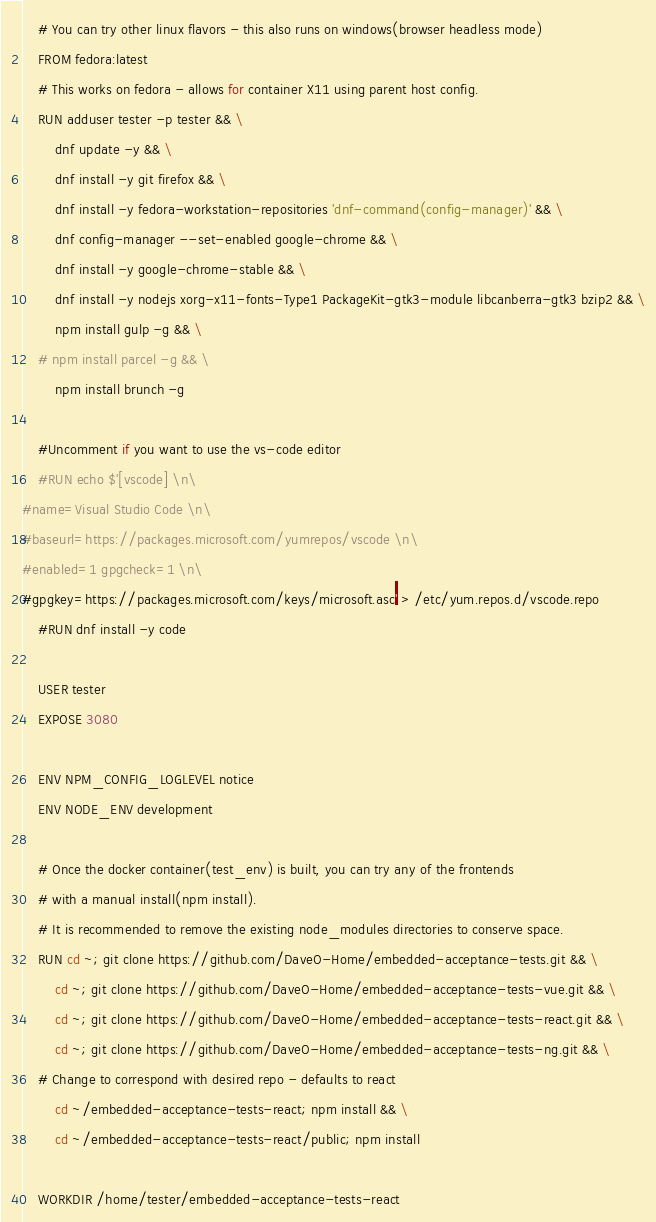<code> <loc_0><loc_0><loc_500><loc_500><_Dockerfile_>    # You can try other linux flavors - this also runs on windows(browser headless mode)
    FROM fedora:latest
    # This works on fedora - allows for container X11 using parent host config.
    RUN adduser tester -p tester && \
        dnf update -y && \
        dnf install -y git firefox && \
        dnf install -y fedora-workstation-repositories 'dnf-command(config-manager)' && \
        dnf config-manager --set-enabled google-chrome && \
        dnf install -y google-chrome-stable && \
        dnf install -y nodejs xorg-x11-fonts-Type1 PackageKit-gtk3-module libcanberra-gtk3 bzip2 && \
        npm install gulp -g && \
    # npm install parcel -g && \
        npm install brunch -g

    #Uncomment if you want to use the vs-code editor
    #RUN echo $'[vscode] \n\
#name=Visual Studio Code \n\
#baseurl=https://packages.microsoft.com/yumrepos/vscode \n\
#enabled=1 gpgcheck=1 \n\
#gpgkey=https://packages.microsoft.com/keys/microsoft.asc' > /etc/yum.repos.d/vscode.repo
    #RUN dnf install -y code

    USER tester
    EXPOSE 3080

    ENV NPM_CONFIG_LOGLEVEL notice
    ENV NODE_ENV development

    # Once the docker container(test_env) is built, you can try any of the frontends 
    # with a manual install(npm install).
    # It is recommended to remove the existing node_modules directories to conserve space.
    RUN cd ~; git clone https://github.com/DaveO-Home/embedded-acceptance-tests.git && \
        cd ~; git clone https://github.com/DaveO-Home/embedded-acceptance-tests-vue.git && \
        cd ~; git clone https://github.com/DaveO-Home/embedded-acceptance-tests-react.git && \
        cd ~; git clone https://github.com/DaveO-Home/embedded-acceptance-tests-ng.git && \
    # Change to correspond with desired repo - defaults to react
        cd ~/embedded-acceptance-tests-react; npm install && \
        cd ~/embedded-acceptance-tests-react/public; npm install
        
    WORKDIR /home/tester/embedded-acceptance-tests-react
</code> 